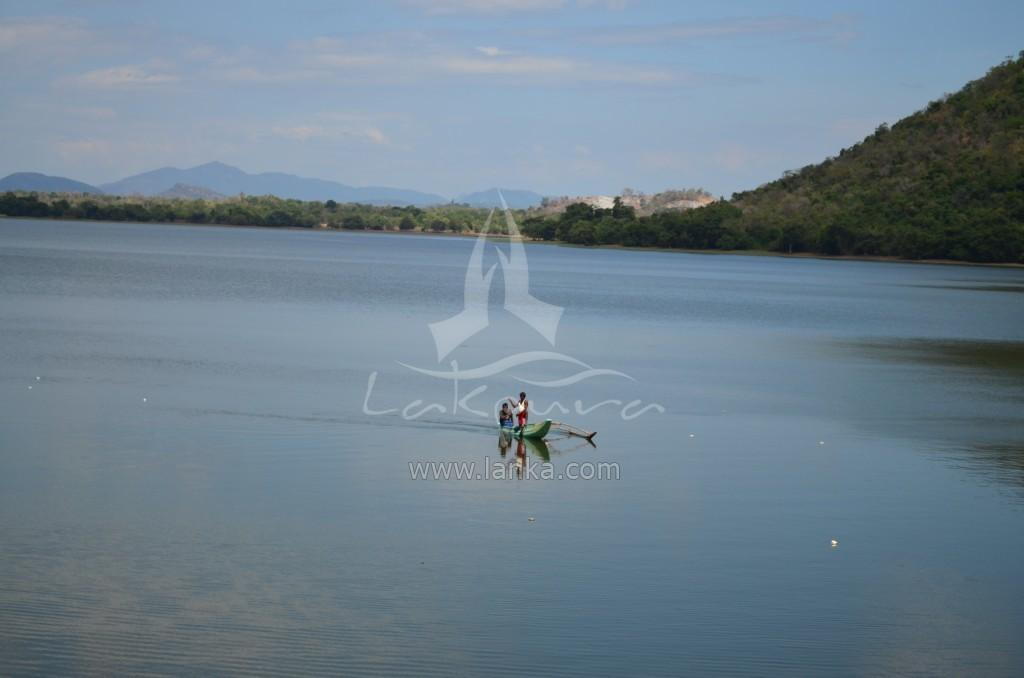How many people are in the image? There are two persons in the image. What are the persons doing in the image? The persons are sitting in a boat. Where is the boat located in the image? The boat is in the middle of a lake. What can be seen in the background of the image? There are hills covered with trees in the background of the image. What is visible in the sky in the image? The sky is visible in the image, and clouds are present. What type of library can be seen in the image? There is no library present in the image; it features two persons sitting in a boat in the middle of a lake. What attraction is the boat heading towards in the image? There is no attraction mentioned or visible in the image; it simply shows two persons sitting in a boat in the middle of a lake. 